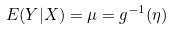<formula> <loc_0><loc_0><loc_500><loc_500>E ( Y | X ) = \mu = g ^ { - 1 } ( \eta )</formula> 